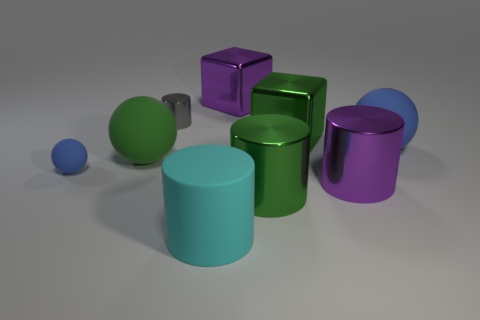What do you think is the material of these objects based on their appearance? Based on their appearances, these objects seem to be made of a smooth, reflective material, perhaps plastic or metal. The way the light bounces off their surfaces suggests they have a glossy finish, typically seen in polished metals or high-quality plastics used in 3D renderings or product designs. 